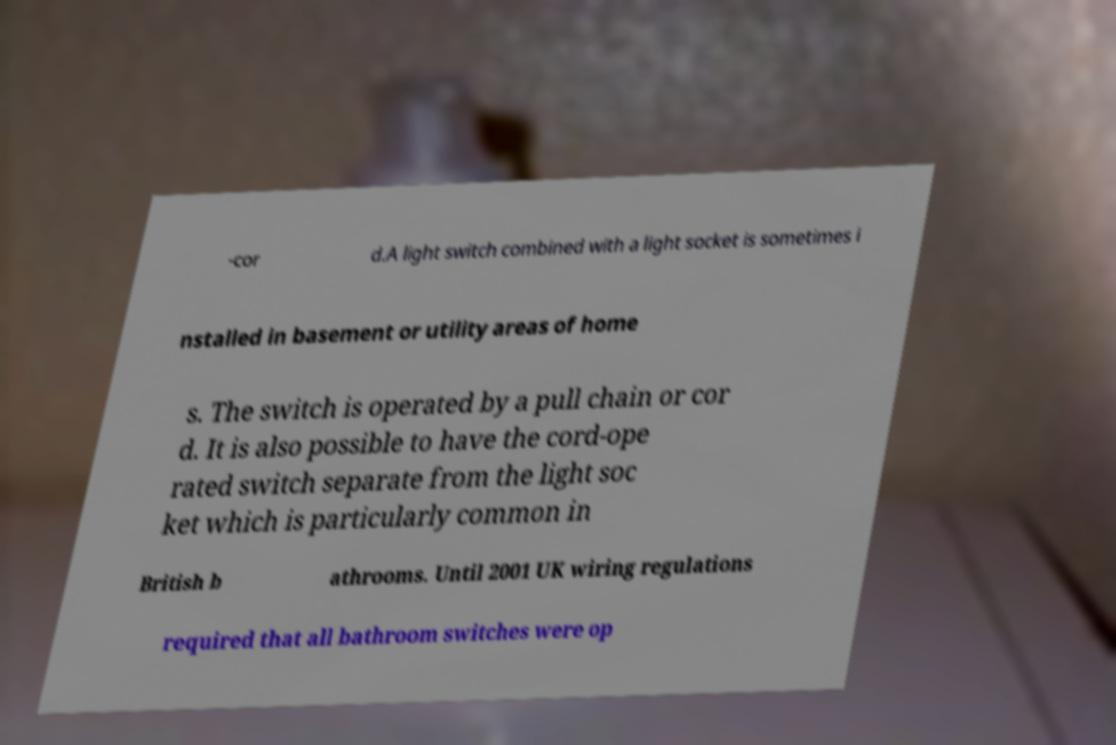Could you assist in decoding the text presented in this image and type it out clearly? -cor d.A light switch combined with a light socket is sometimes i nstalled in basement or utility areas of home s. The switch is operated by a pull chain or cor d. It is also possible to have the cord-ope rated switch separate from the light soc ket which is particularly common in British b athrooms. Until 2001 UK wiring regulations required that all bathroom switches were op 